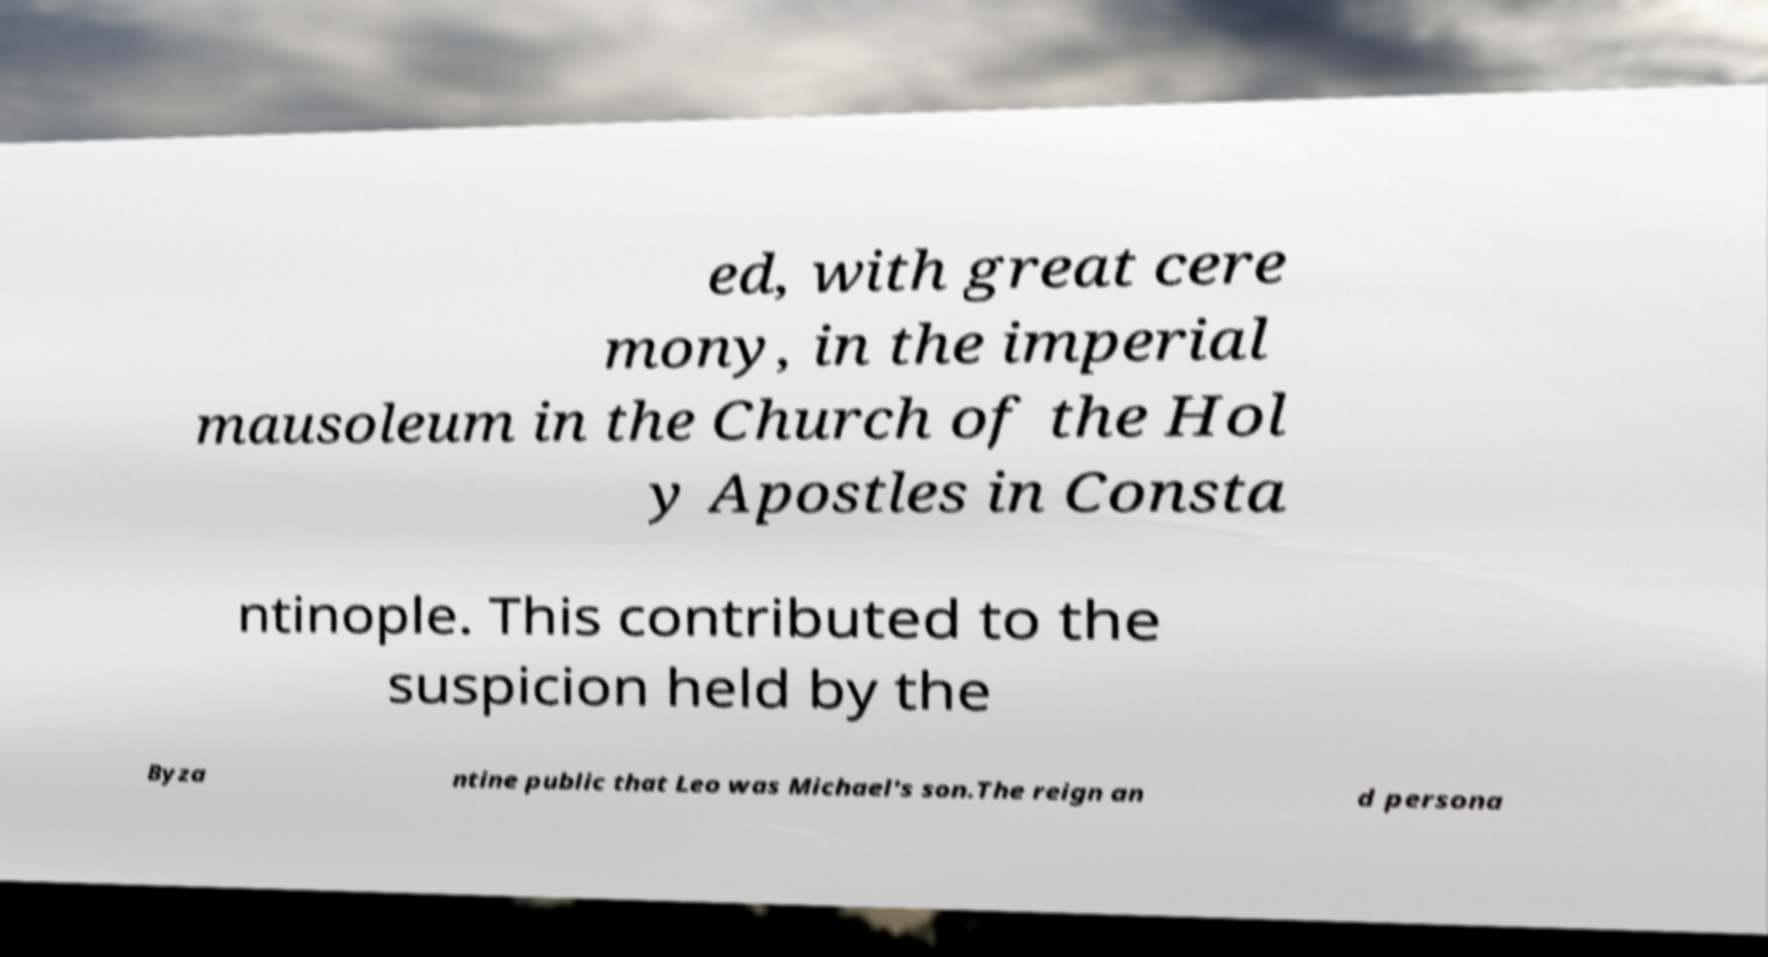What messages or text are displayed in this image? I need them in a readable, typed format. ed, with great cere mony, in the imperial mausoleum in the Church of the Hol y Apostles in Consta ntinople. This contributed to the suspicion held by the Byza ntine public that Leo was Michael's son.The reign an d persona 